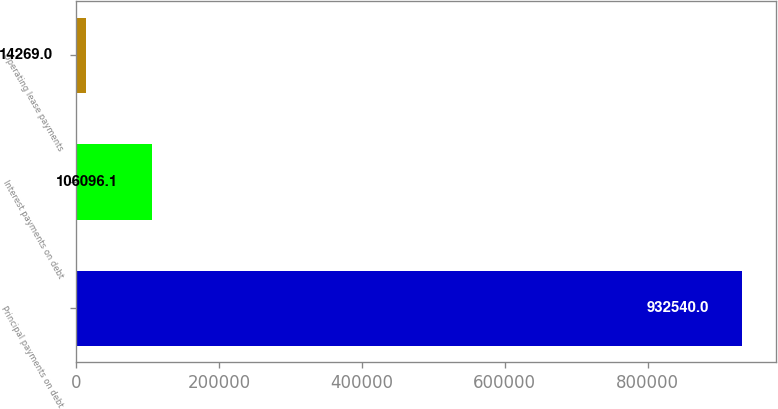<chart> <loc_0><loc_0><loc_500><loc_500><bar_chart><fcel>Principal payments on debt<fcel>Interest payments on debt<fcel>Operating lease payments<nl><fcel>932540<fcel>106096<fcel>14269<nl></chart> 